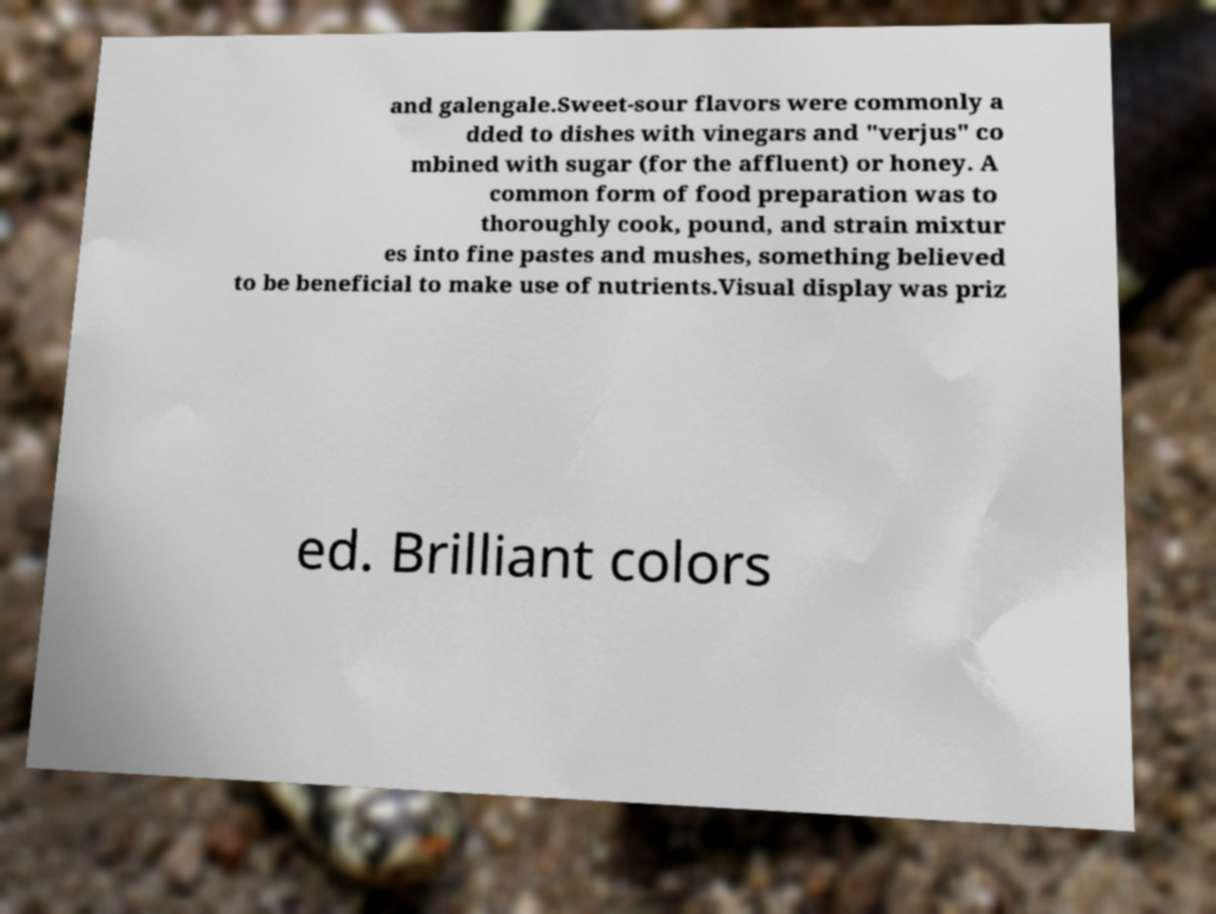What messages or text are displayed in this image? I need them in a readable, typed format. and galengale.Sweet-sour flavors were commonly a dded to dishes with vinegars and "verjus" co mbined with sugar (for the affluent) or honey. A common form of food preparation was to thoroughly cook, pound, and strain mixtur es into fine pastes and mushes, something believed to be beneficial to make use of nutrients.Visual display was priz ed. Brilliant colors 